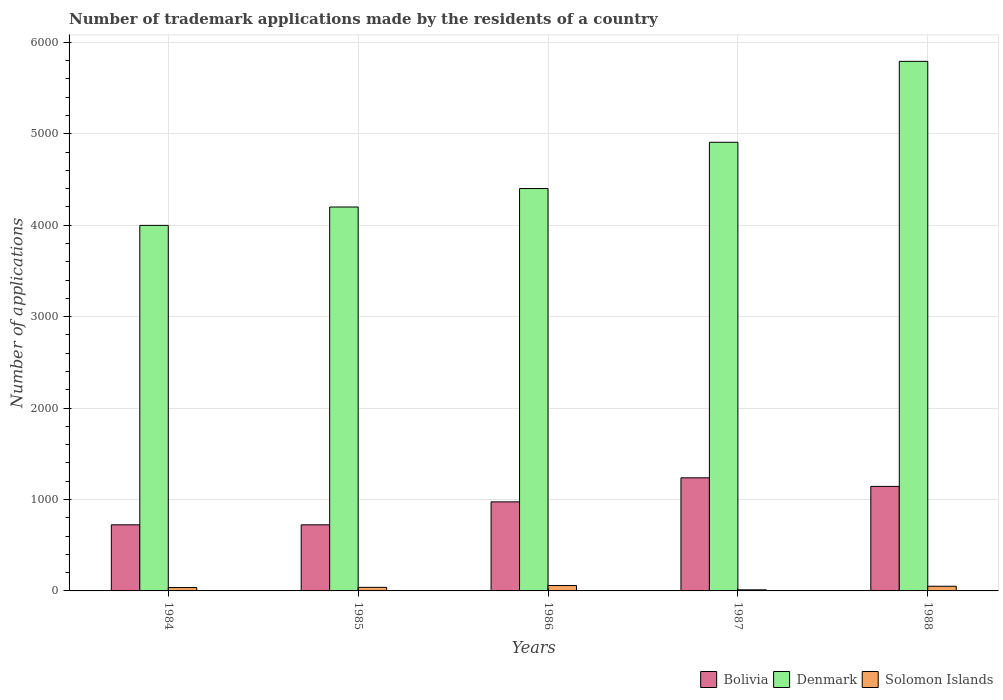How many groups of bars are there?
Ensure brevity in your answer.  5. Are the number of bars per tick equal to the number of legend labels?
Provide a short and direct response. Yes. Are the number of bars on each tick of the X-axis equal?
Offer a terse response. Yes. What is the number of trademark applications made by the residents in Bolivia in 1986?
Give a very brief answer. 974. Across all years, what is the maximum number of trademark applications made by the residents in Solomon Islands?
Keep it short and to the point. 59. In which year was the number of trademark applications made by the residents in Denmark minimum?
Offer a very short reply. 1984. What is the total number of trademark applications made by the residents in Denmark in the graph?
Offer a very short reply. 2.33e+04. What is the difference between the number of trademark applications made by the residents in Denmark in 1987 and the number of trademark applications made by the residents in Bolivia in 1984?
Provide a succinct answer. 4184. What is the average number of trademark applications made by the residents in Denmark per year?
Offer a terse response. 4659.4. In the year 1988, what is the difference between the number of trademark applications made by the residents in Solomon Islands and number of trademark applications made by the residents in Bolivia?
Give a very brief answer. -1092. What is the ratio of the number of trademark applications made by the residents in Solomon Islands in 1984 to that in 1985?
Your response must be concise. 0.95. Is the number of trademark applications made by the residents in Denmark in 1984 less than that in 1988?
Your response must be concise. Yes. What is the difference between the highest and the second highest number of trademark applications made by the residents in Solomon Islands?
Give a very brief answer. 8. What is the difference between the highest and the lowest number of trademark applications made by the residents in Denmark?
Keep it short and to the point. 1794. What does the 1st bar from the right in 1984 represents?
Make the answer very short. Solomon Islands. How many bars are there?
Make the answer very short. 15. Are all the bars in the graph horizontal?
Your answer should be very brief. No. What is the difference between two consecutive major ticks on the Y-axis?
Your response must be concise. 1000. Are the values on the major ticks of Y-axis written in scientific E-notation?
Your answer should be very brief. No. Does the graph contain any zero values?
Keep it short and to the point. No. Where does the legend appear in the graph?
Make the answer very short. Bottom right. What is the title of the graph?
Make the answer very short. Number of trademark applications made by the residents of a country. What is the label or title of the X-axis?
Offer a very short reply. Years. What is the label or title of the Y-axis?
Your answer should be very brief. Number of applications. What is the Number of applications of Bolivia in 1984?
Your response must be concise. 723. What is the Number of applications in Denmark in 1984?
Offer a terse response. 3998. What is the Number of applications of Bolivia in 1985?
Your response must be concise. 723. What is the Number of applications in Denmark in 1985?
Give a very brief answer. 4199. What is the Number of applications in Bolivia in 1986?
Your answer should be very brief. 974. What is the Number of applications of Denmark in 1986?
Your response must be concise. 4401. What is the Number of applications of Solomon Islands in 1986?
Give a very brief answer. 59. What is the Number of applications in Bolivia in 1987?
Your response must be concise. 1237. What is the Number of applications in Denmark in 1987?
Ensure brevity in your answer.  4907. What is the Number of applications of Bolivia in 1988?
Make the answer very short. 1143. What is the Number of applications in Denmark in 1988?
Your response must be concise. 5792. What is the Number of applications of Solomon Islands in 1988?
Offer a terse response. 51. Across all years, what is the maximum Number of applications of Bolivia?
Make the answer very short. 1237. Across all years, what is the maximum Number of applications of Denmark?
Give a very brief answer. 5792. Across all years, what is the maximum Number of applications in Solomon Islands?
Offer a very short reply. 59. Across all years, what is the minimum Number of applications in Bolivia?
Ensure brevity in your answer.  723. Across all years, what is the minimum Number of applications of Denmark?
Ensure brevity in your answer.  3998. What is the total Number of applications of Bolivia in the graph?
Your response must be concise. 4800. What is the total Number of applications in Denmark in the graph?
Your response must be concise. 2.33e+04. What is the total Number of applications in Solomon Islands in the graph?
Make the answer very short. 198. What is the difference between the Number of applications of Denmark in 1984 and that in 1985?
Offer a terse response. -201. What is the difference between the Number of applications of Solomon Islands in 1984 and that in 1985?
Make the answer very short. -2. What is the difference between the Number of applications of Bolivia in 1984 and that in 1986?
Keep it short and to the point. -251. What is the difference between the Number of applications in Denmark in 1984 and that in 1986?
Your answer should be very brief. -403. What is the difference between the Number of applications in Bolivia in 1984 and that in 1987?
Your response must be concise. -514. What is the difference between the Number of applications of Denmark in 1984 and that in 1987?
Give a very brief answer. -909. What is the difference between the Number of applications of Solomon Islands in 1984 and that in 1987?
Your answer should be compact. 25. What is the difference between the Number of applications in Bolivia in 1984 and that in 1988?
Keep it short and to the point. -420. What is the difference between the Number of applications in Denmark in 1984 and that in 1988?
Your answer should be compact. -1794. What is the difference between the Number of applications in Bolivia in 1985 and that in 1986?
Offer a very short reply. -251. What is the difference between the Number of applications of Denmark in 1985 and that in 1986?
Make the answer very short. -202. What is the difference between the Number of applications in Bolivia in 1985 and that in 1987?
Your answer should be very brief. -514. What is the difference between the Number of applications in Denmark in 1985 and that in 1987?
Provide a succinct answer. -708. What is the difference between the Number of applications of Solomon Islands in 1985 and that in 1987?
Keep it short and to the point. 27. What is the difference between the Number of applications in Bolivia in 1985 and that in 1988?
Make the answer very short. -420. What is the difference between the Number of applications of Denmark in 1985 and that in 1988?
Provide a short and direct response. -1593. What is the difference between the Number of applications of Solomon Islands in 1985 and that in 1988?
Your response must be concise. -12. What is the difference between the Number of applications in Bolivia in 1986 and that in 1987?
Offer a very short reply. -263. What is the difference between the Number of applications in Denmark in 1986 and that in 1987?
Give a very brief answer. -506. What is the difference between the Number of applications in Bolivia in 1986 and that in 1988?
Keep it short and to the point. -169. What is the difference between the Number of applications of Denmark in 1986 and that in 1988?
Your response must be concise. -1391. What is the difference between the Number of applications in Bolivia in 1987 and that in 1988?
Provide a succinct answer. 94. What is the difference between the Number of applications in Denmark in 1987 and that in 1988?
Provide a succinct answer. -885. What is the difference between the Number of applications of Solomon Islands in 1987 and that in 1988?
Provide a short and direct response. -39. What is the difference between the Number of applications of Bolivia in 1984 and the Number of applications of Denmark in 1985?
Keep it short and to the point. -3476. What is the difference between the Number of applications of Bolivia in 1984 and the Number of applications of Solomon Islands in 1985?
Offer a very short reply. 684. What is the difference between the Number of applications of Denmark in 1984 and the Number of applications of Solomon Islands in 1985?
Provide a succinct answer. 3959. What is the difference between the Number of applications in Bolivia in 1984 and the Number of applications in Denmark in 1986?
Give a very brief answer. -3678. What is the difference between the Number of applications of Bolivia in 1984 and the Number of applications of Solomon Islands in 1986?
Your answer should be compact. 664. What is the difference between the Number of applications in Denmark in 1984 and the Number of applications in Solomon Islands in 1986?
Your answer should be compact. 3939. What is the difference between the Number of applications in Bolivia in 1984 and the Number of applications in Denmark in 1987?
Your answer should be compact. -4184. What is the difference between the Number of applications of Bolivia in 1984 and the Number of applications of Solomon Islands in 1987?
Your response must be concise. 711. What is the difference between the Number of applications of Denmark in 1984 and the Number of applications of Solomon Islands in 1987?
Your answer should be compact. 3986. What is the difference between the Number of applications in Bolivia in 1984 and the Number of applications in Denmark in 1988?
Your response must be concise. -5069. What is the difference between the Number of applications in Bolivia in 1984 and the Number of applications in Solomon Islands in 1988?
Your answer should be compact. 672. What is the difference between the Number of applications in Denmark in 1984 and the Number of applications in Solomon Islands in 1988?
Make the answer very short. 3947. What is the difference between the Number of applications of Bolivia in 1985 and the Number of applications of Denmark in 1986?
Give a very brief answer. -3678. What is the difference between the Number of applications of Bolivia in 1985 and the Number of applications of Solomon Islands in 1986?
Provide a succinct answer. 664. What is the difference between the Number of applications of Denmark in 1985 and the Number of applications of Solomon Islands in 1986?
Your answer should be compact. 4140. What is the difference between the Number of applications of Bolivia in 1985 and the Number of applications of Denmark in 1987?
Your answer should be compact. -4184. What is the difference between the Number of applications of Bolivia in 1985 and the Number of applications of Solomon Islands in 1987?
Your answer should be compact. 711. What is the difference between the Number of applications in Denmark in 1985 and the Number of applications in Solomon Islands in 1987?
Your response must be concise. 4187. What is the difference between the Number of applications in Bolivia in 1985 and the Number of applications in Denmark in 1988?
Keep it short and to the point. -5069. What is the difference between the Number of applications of Bolivia in 1985 and the Number of applications of Solomon Islands in 1988?
Offer a terse response. 672. What is the difference between the Number of applications of Denmark in 1985 and the Number of applications of Solomon Islands in 1988?
Give a very brief answer. 4148. What is the difference between the Number of applications in Bolivia in 1986 and the Number of applications in Denmark in 1987?
Offer a terse response. -3933. What is the difference between the Number of applications in Bolivia in 1986 and the Number of applications in Solomon Islands in 1987?
Offer a very short reply. 962. What is the difference between the Number of applications of Denmark in 1986 and the Number of applications of Solomon Islands in 1987?
Keep it short and to the point. 4389. What is the difference between the Number of applications in Bolivia in 1986 and the Number of applications in Denmark in 1988?
Provide a short and direct response. -4818. What is the difference between the Number of applications of Bolivia in 1986 and the Number of applications of Solomon Islands in 1988?
Provide a short and direct response. 923. What is the difference between the Number of applications in Denmark in 1986 and the Number of applications in Solomon Islands in 1988?
Keep it short and to the point. 4350. What is the difference between the Number of applications of Bolivia in 1987 and the Number of applications of Denmark in 1988?
Give a very brief answer. -4555. What is the difference between the Number of applications in Bolivia in 1987 and the Number of applications in Solomon Islands in 1988?
Provide a succinct answer. 1186. What is the difference between the Number of applications in Denmark in 1987 and the Number of applications in Solomon Islands in 1988?
Your answer should be compact. 4856. What is the average Number of applications of Bolivia per year?
Give a very brief answer. 960. What is the average Number of applications of Denmark per year?
Ensure brevity in your answer.  4659.4. What is the average Number of applications in Solomon Islands per year?
Make the answer very short. 39.6. In the year 1984, what is the difference between the Number of applications of Bolivia and Number of applications of Denmark?
Offer a terse response. -3275. In the year 1984, what is the difference between the Number of applications of Bolivia and Number of applications of Solomon Islands?
Your answer should be very brief. 686. In the year 1984, what is the difference between the Number of applications of Denmark and Number of applications of Solomon Islands?
Keep it short and to the point. 3961. In the year 1985, what is the difference between the Number of applications in Bolivia and Number of applications in Denmark?
Provide a short and direct response. -3476. In the year 1985, what is the difference between the Number of applications of Bolivia and Number of applications of Solomon Islands?
Provide a succinct answer. 684. In the year 1985, what is the difference between the Number of applications of Denmark and Number of applications of Solomon Islands?
Provide a short and direct response. 4160. In the year 1986, what is the difference between the Number of applications in Bolivia and Number of applications in Denmark?
Offer a very short reply. -3427. In the year 1986, what is the difference between the Number of applications of Bolivia and Number of applications of Solomon Islands?
Your answer should be compact. 915. In the year 1986, what is the difference between the Number of applications of Denmark and Number of applications of Solomon Islands?
Provide a succinct answer. 4342. In the year 1987, what is the difference between the Number of applications in Bolivia and Number of applications in Denmark?
Offer a very short reply. -3670. In the year 1987, what is the difference between the Number of applications of Bolivia and Number of applications of Solomon Islands?
Offer a terse response. 1225. In the year 1987, what is the difference between the Number of applications in Denmark and Number of applications in Solomon Islands?
Provide a succinct answer. 4895. In the year 1988, what is the difference between the Number of applications in Bolivia and Number of applications in Denmark?
Offer a terse response. -4649. In the year 1988, what is the difference between the Number of applications of Bolivia and Number of applications of Solomon Islands?
Your answer should be compact. 1092. In the year 1988, what is the difference between the Number of applications in Denmark and Number of applications in Solomon Islands?
Provide a succinct answer. 5741. What is the ratio of the Number of applications of Bolivia in 1984 to that in 1985?
Offer a very short reply. 1. What is the ratio of the Number of applications in Denmark in 1984 to that in 1985?
Make the answer very short. 0.95. What is the ratio of the Number of applications in Solomon Islands in 1984 to that in 1985?
Ensure brevity in your answer.  0.95. What is the ratio of the Number of applications of Bolivia in 1984 to that in 1986?
Offer a very short reply. 0.74. What is the ratio of the Number of applications of Denmark in 1984 to that in 1986?
Give a very brief answer. 0.91. What is the ratio of the Number of applications in Solomon Islands in 1984 to that in 1986?
Make the answer very short. 0.63. What is the ratio of the Number of applications of Bolivia in 1984 to that in 1987?
Offer a terse response. 0.58. What is the ratio of the Number of applications of Denmark in 1984 to that in 1987?
Provide a short and direct response. 0.81. What is the ratio of the Number of applications of Solomon Islands in 1984 to that in 1987?
Offer a terse response. 3.08. What is the ratio of the Number of applications in Bolivia in 1984 to that in 1988?
Provide a short and direct response. 0.63. What is the ratio of the Number of applications in Denmark in 1984 to that in 1988?
Provide a short and direct response. 0.69. What is the ratio of the Number of applications of Solomon Islands in 1984 to that in 1988?
Give a very brief answer. 0.73. What is the ratio of the Number of applications in Bolivia in 1985 to that in 1986?
Offer a very short reply. 0.74. What is the ratio of the Number of applications in Denmark in 1985 to that in 1986?
Give a very brief answer. 0.95. What is the ratio of the Number of applications of Solomon Islands in 1985 to that in 1986?
Provide a short and direct response. 0.66. What is the ratio of the Number of applications in Bolivia in 1985 to that in 1987?
Offer a terse response. 0.58. What is the ratio of the Number of applications of Denmark in 1985 to that in 1987?
Offer a terse response. 0.86. What is the ratio of the Number of applications of Solomon Islands in 1985 to that in 1987?
Keep it short and to the point. 3.25. What is the ratio of the Number of applications in Bolivia in 1985 to that in 1988?
Offer a very short reply. 0.63. What is the ratio of the Number of applications of Denmark in 1985 to that in 1988?
Offer a terse response. 0.72. What is the ratio of the Number of applications in Solomon Islands in 1985 to that in 1988?
Ensure brevity in your answer.  0.76. What is the ratio of the Number of applications of Bolivia in 1986 to that in 1987?
Provide a succinct answer. 0.79. What is the ratio of the Number of applications in Denmark in 1986 to that in 1987?
Your answer should be compact. 0.9. What is the ratio of the Number of applications of Solomon Islands in 1986 to that in 1987?
Your answer should be very brief. 4.92. What is the ratio of the Number of applications in Bolivia in 1986 to that in 1988?
Ensure brevity in your answer.  0.85. What is the ratio of the Number of applications in Denmark in 1986 to that in 1988?
Offer a terse response. 0.76. What is the ratio of the Number of applications in Solomon Islands in 1986 to that in 1988?
Provide a succinct answer. 1.16. What is the ratio of the Number of applications in Bolivia in 1987 to that in 1988?
Provide a succinct answer. 1.08. What is the ratio of the Number of applications of Denmark in 1987 to that in 1988?
Your answer should be very brief. 0.85. What is the ratio of the Number of applications in Solomon Islands in 1987 to that in 1988?
Make the answer very short. 0.24. What is the difference between the highest and the second highest Number of applications in Bolivia?
Provide a short and direct response. 94. What is the difference between the highest and the second highest Number of applications of Denmark?
Ensure brevity in your answer.  885. What is the difference between the highest and the second highest Number of applications of Solomon Islands?
Your answer should be very brief. 8. What is the difference between the highest and the lowest Number of applications of Bolivia?
Ensure brevity in your answer.  514. What is the difference between the highest and the lowest Number of applications of Denmark?
Your response must be concise. 1794. 